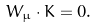<formula> <loc_0><loc_0><loc_500><loc_500>{ W } _ { \mu } \cdot { K } = 0 .</formula> 